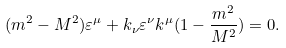<formula> <loc_0><loc_0><loc_500><loc_500>( m ^ { 2 } - M ^ { 2 } ) \varepsilon ^ { \mu } + k _ { \nu } \varepsilon ^ { \nu } k ^ { \mu } ( 1 - \frac { m ^ { 2 } } { M ^ { 2 } } ) = 0 .</formula> 